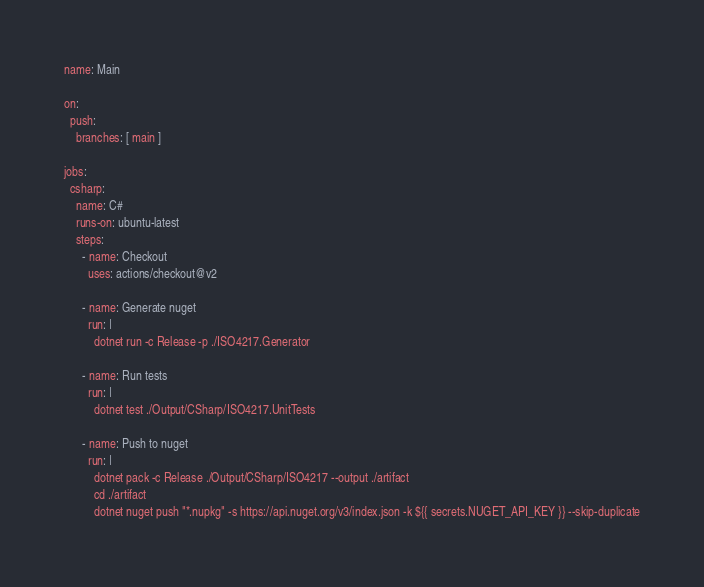<code> <loc_0><loc_0><loc_500><loc_500><_YAML_>name: Main

on:
  push:
    branches: [ main ]

jobs:
  csharp:
    name: C#
    runs-on: ubuntu-latest
    steps:
      - name: Checkout
        uses: actions/checkout@v2

      - name: Generate nuget
        run: |
          dotnet run -c Release -p ./ISO4217.Generator

      - name: Run tests
        run: |
          dotnet test ./Output/CSharp/ISO4217.UnitTests

      - name: Push to nuget
        run: |
          dotnet pack -c Release ./Output/CSharp/ISO4217 --output ./artifact
          cd ./artifact
          dotnet nuget push "*.nupkg" -s https://api.nuget.org/v3/index.json -k ${{ secrets.NUGET_API_KEY }} --skip-duplicate
</code> 